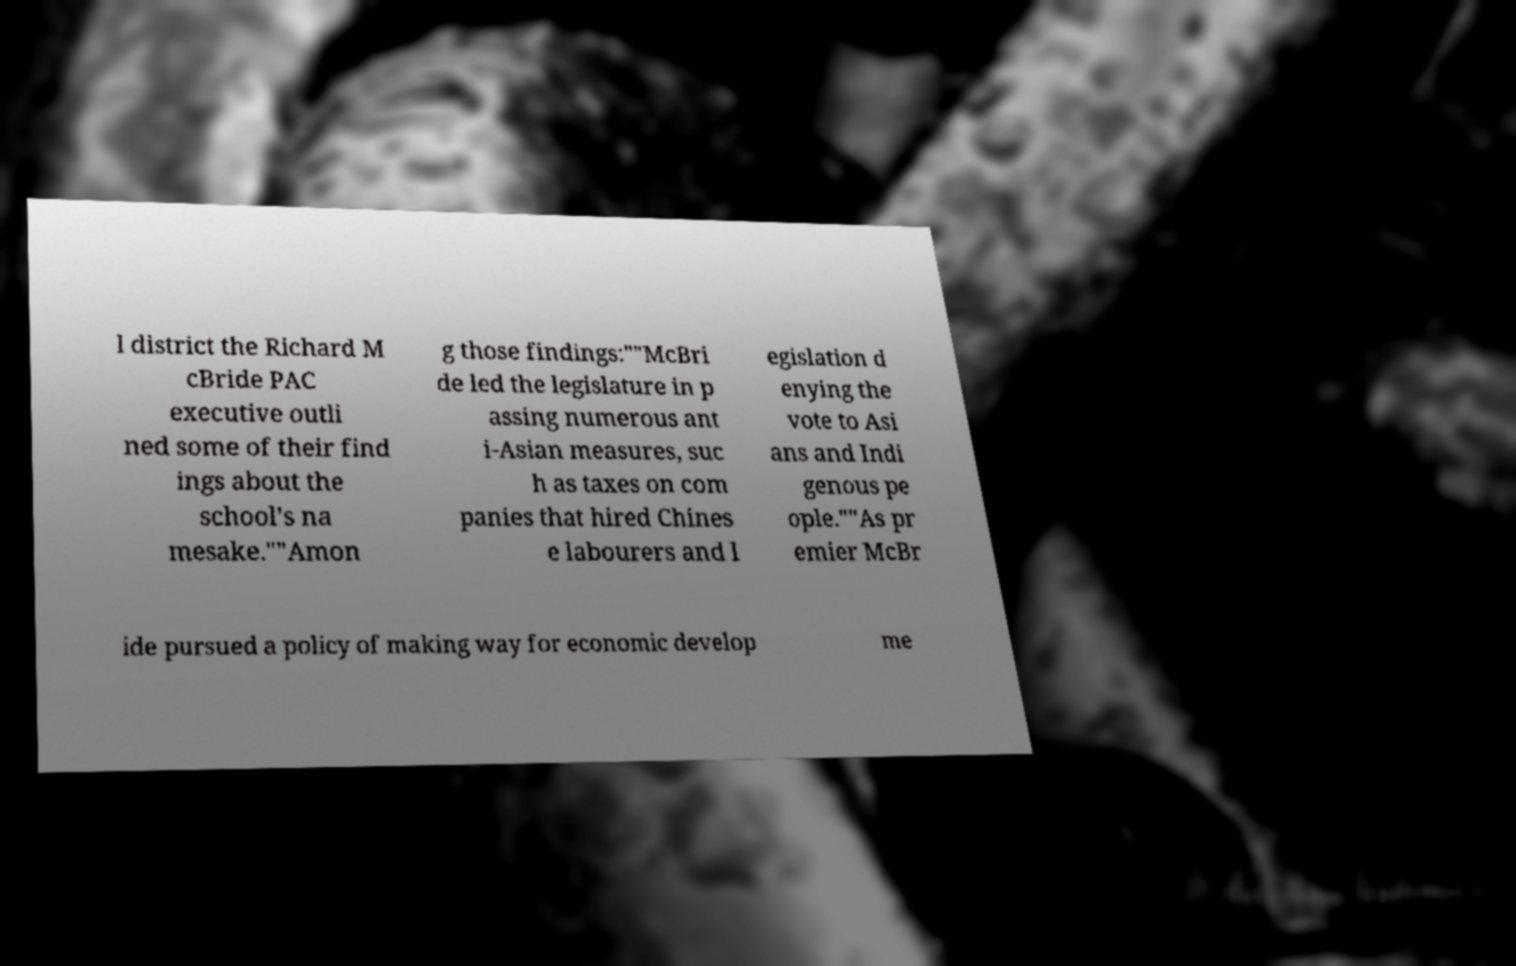Could you extract and type out the text from this image? l district the Richard M cBride PAC executive outli ned some of their find ings about the school’s na mesake.""Amon g those findings:""McBri de led the legislature in p assing numerous ant i-Asian measures, suc h as taxes on com panies that hired Chines e labourers and l egislation d enying the vote to Asi ans and Indi genous pe ople.""As pr emier McBr ide pursued a policy of making way for economic develop me 